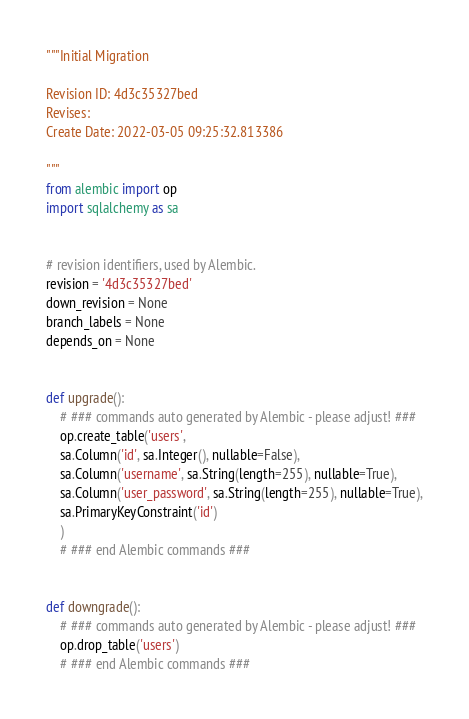<code> <loc_0><loc_0><loc_500><loc_500><_Python_>"""Initial Migration

Revision ID: 4d3c35327bed
Revises: 
Create Date: 2022-03-05 09:25:32.813386

"""
from alembic import op
import sqlalchemy as sa


# revision identifiers, used by Alembic.
revision = '4d3c35327bed'
down_revision = None
branch_labels = None
depends_on = None


def upgrade():
    # ### commands auto generated by Alembic - please adjust! ###
    op.create_table('users',
    sa.Column('id', sa.Integer(), nullable=False),
    sa.Column('username', sa.String(length=255), nullable=True),
    sa.Column('user_password', sa.String(length=255), nullable=True),
    sa.PrimaryKeyConstraint('id')
    )
    # ### end Alembic commands ###


def downgrade():
    # ### commands auto generated by Alembic - please adjust! ###
    op.drop_table('users')
    # ### end Alembic commands ###
</code> 